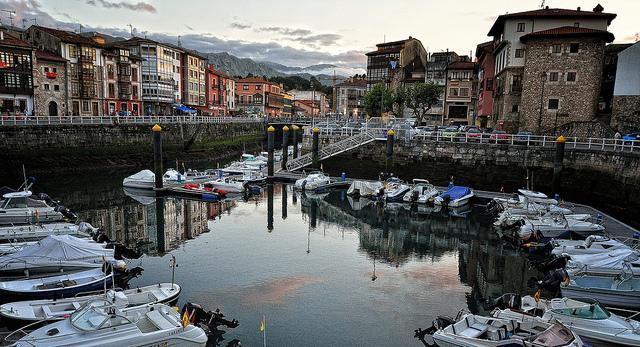Are there many buildings in the picture?
Short answer required. Yes. Are there clouds in the sky?
Keep it brief. Yes. What is in the water?
Quick response, please. Boats. How many red cars can you spot?
Write a very short answer. 2. 